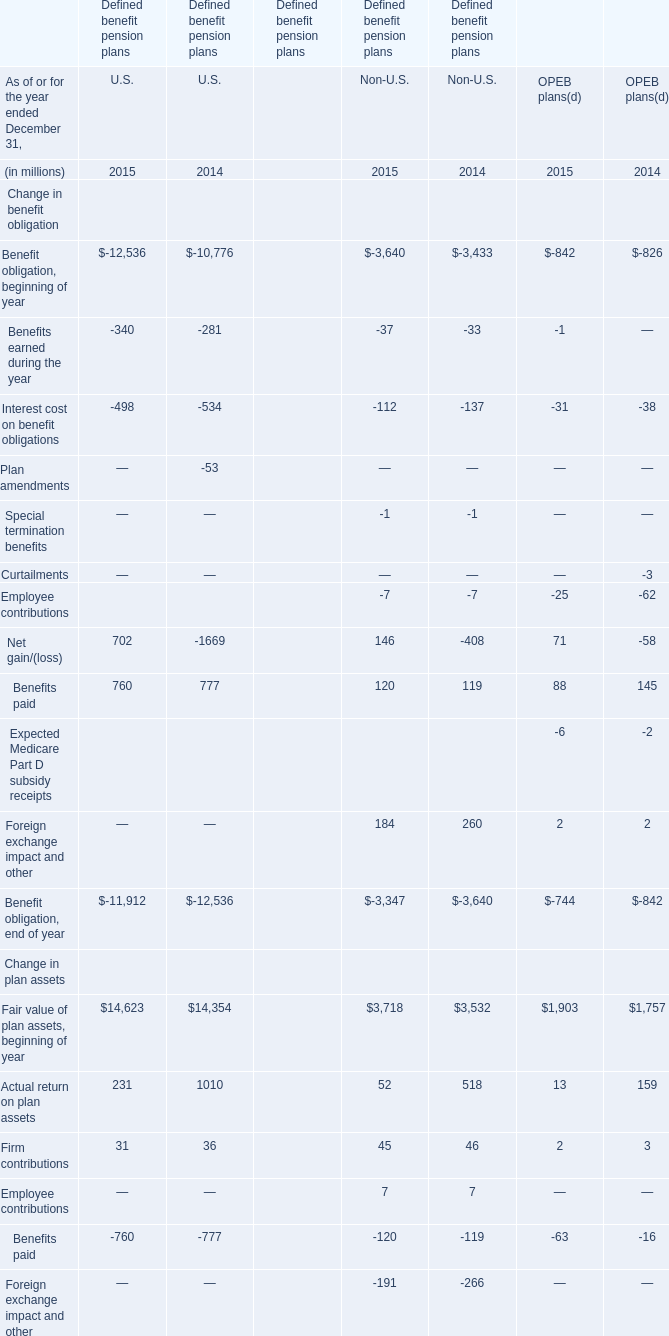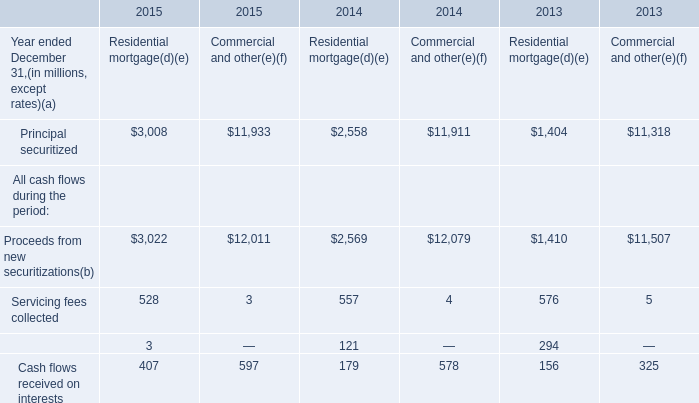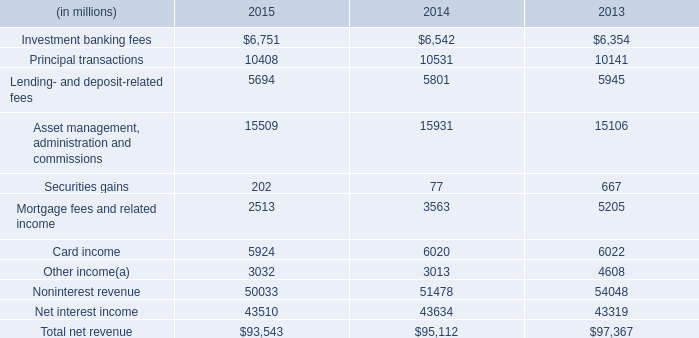What will Actual return on plan assets in terms of OPEB plans reach in 2016 if it continues to grow at its current rate? (in million) 
Computations: (13 * (1 + ((13 - 159) / 159)))
Answer: 1.06289. 